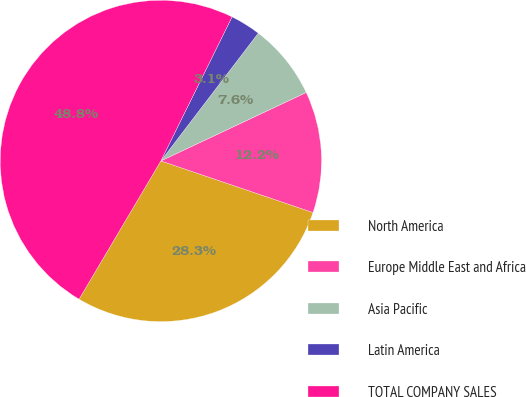Convert chart to OTSL. <chart><loc_0><loc_0><loc_500><loc_500><pie_chart><fcel>North America<fcel>Europe Middle East and Africa<fcel>Asia Pacific<fcel>Latin America<fcel>TOTAL COMPANY SALES<nl><fcel>28.3%<fcel>12.21%<fcel>7.63%<fcel>3.06%<fcel>48.81%<nl></chart> 